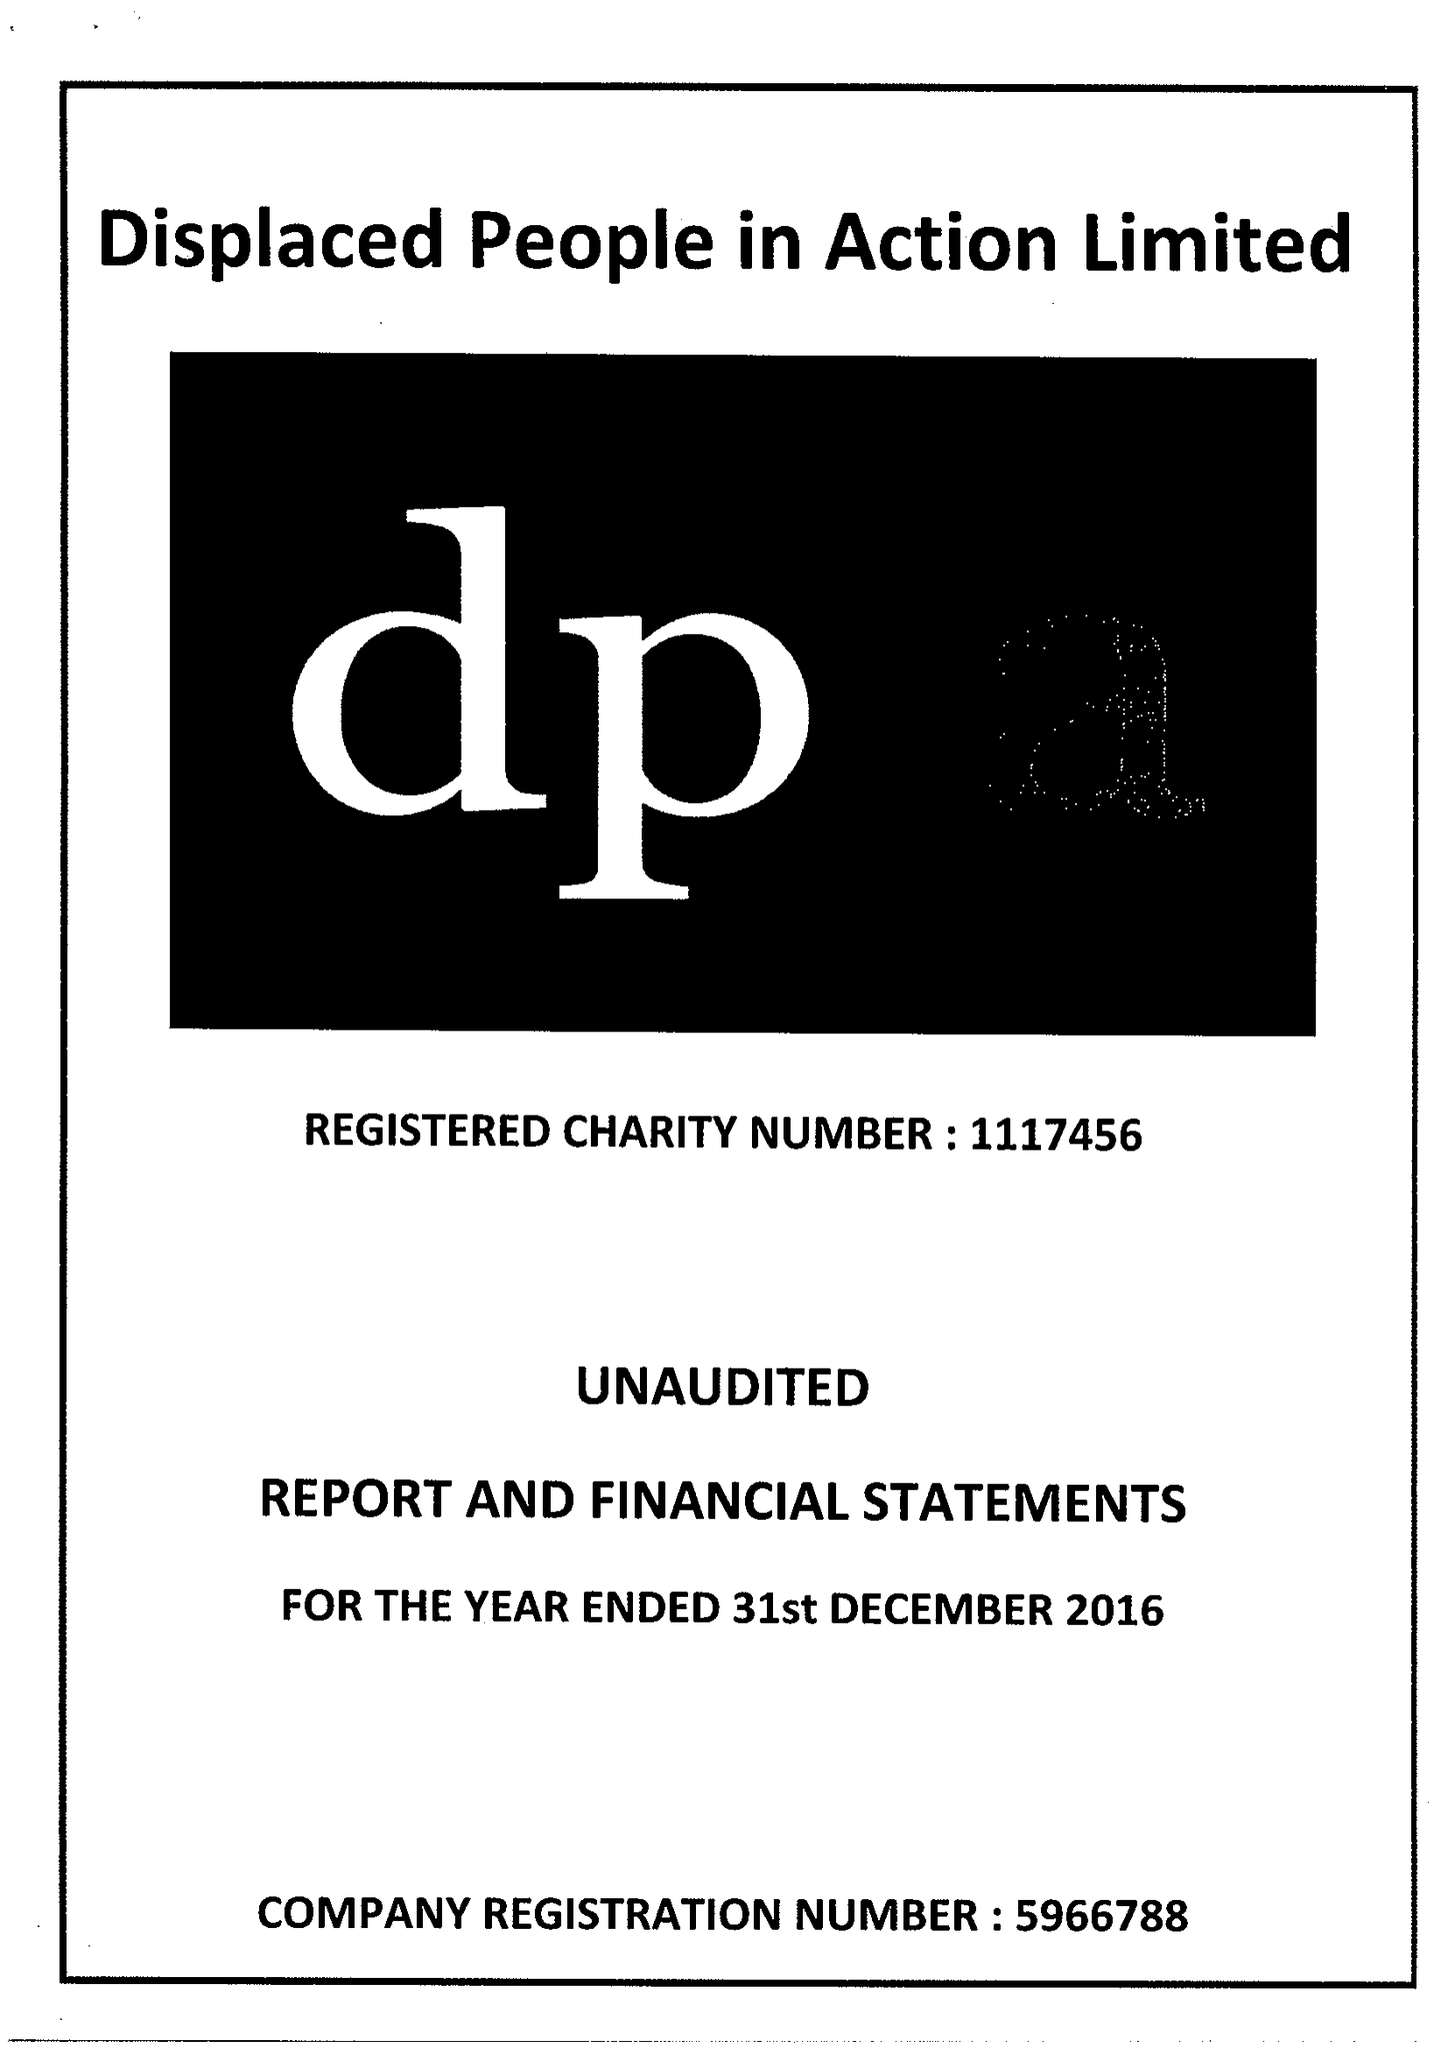What is the value for the address__postcode?
Answer the question using a single word or phrase. CF24 0BL 